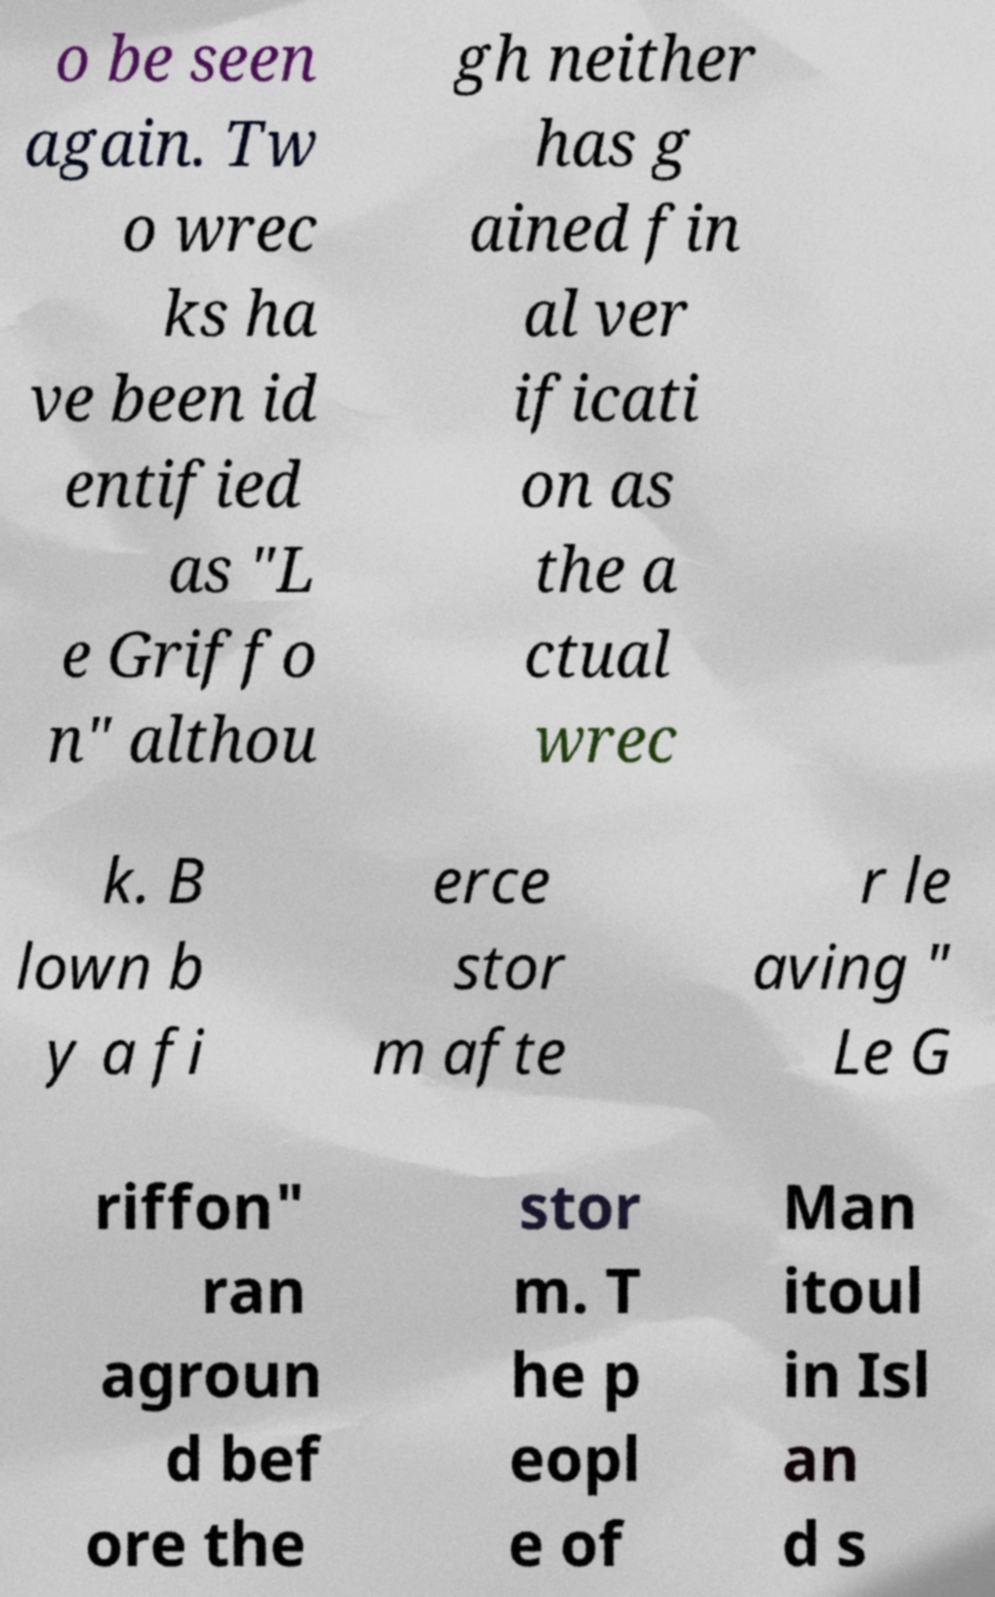Can you read and provide the text displayed in the image?This photo seems to have some interesting text. Can you extract and type it out for me? o be seen again. Tw o wrec ks ha ve been id entified as "L e Griffo n" althou gh neither has g ained fin al ver ificati on as the a ctual wrec k. B lown b y a fi erce stor m afte r le aving " Le G riffon" ran agroun d bef ore the stor m. T he p eopl e of Man itoul in Isl an d s 